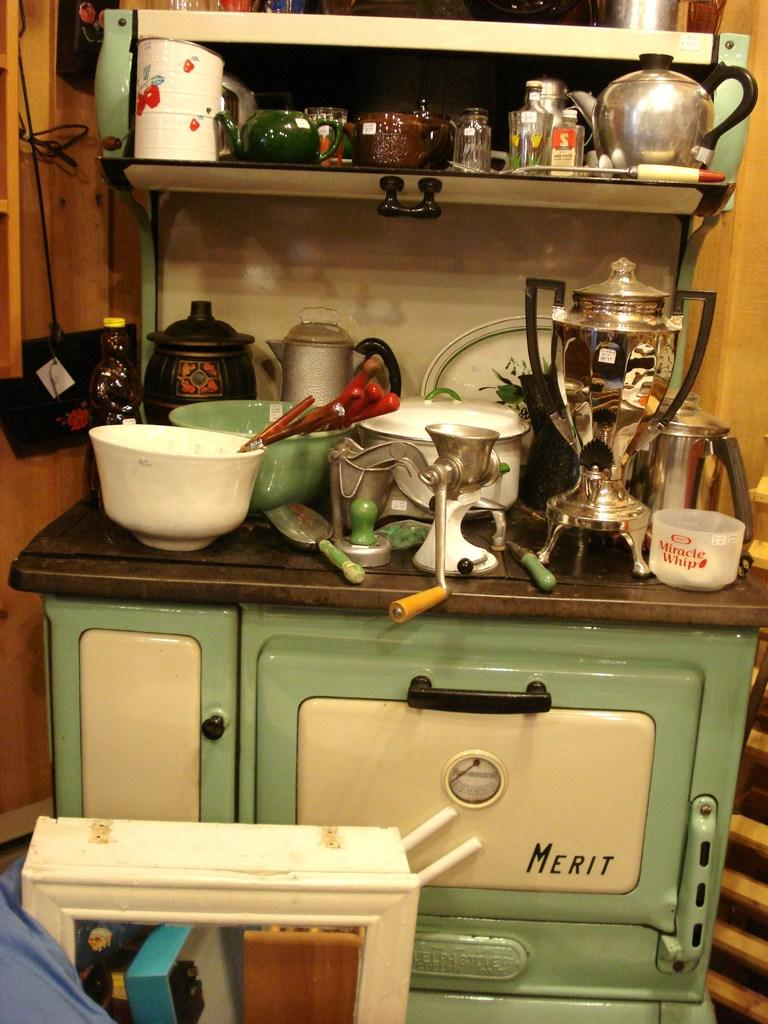<image>
Give a short and clear explanation of the subsequent image. A bunch of dirty plates sit on top of a Merit stove. 